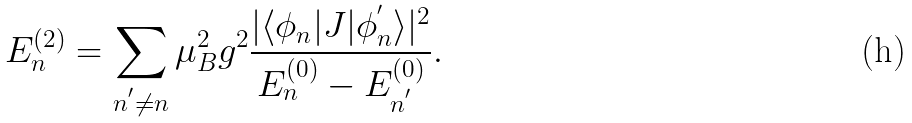<formula> <loc_0><loc_0><loc_500><loc_500>E _ { n } ^ { ( 2 ) } = \sum _ { n ^ { ^ { \prime } } \neq n } \mu _ { B } ^ { 2 } g ^ { 2 } \frac { | \langle \phi _ { n } | J | \phi _ { n } ^ { ^ { \prime } } \rangle | ^ { 2 } } { E _ { n } ^ { ( 0 ) } - E _ { n ^ { ^ { \prime } } } ^ { ( 0 ) } } .</formula> 